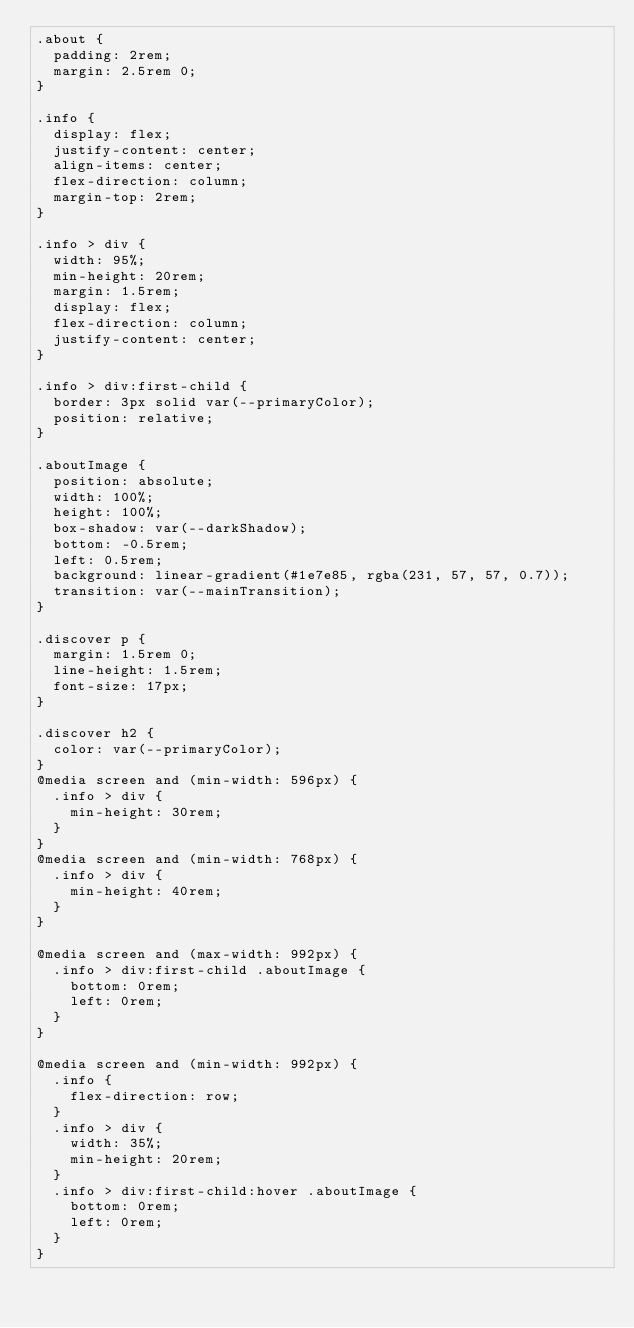<code> <loc_0><loc_0><loc_500><loc_500><_CSS_>.about {
  padding: 2rem;
  margin: 2.5rem 0;
}

.info {
  display: flex;
  justify-content: center;
  align-items: center;
  flex-direction: column;
  margin-top: 2rem;
}

.info > div {
  width: 95%;
  min-height: 20rem;
  margin: 1.5rem;
  display: flex;
  flex-direction: column;
  justify-content: center;
}

.info > div:first-child {
  border: 3px solid var(--primaryColor);
  position: relative;
}

.aboutImage {
  position: absolute;
  width: 100%;
  height: 100%;
  box-shadow: var(--darkShadow);
  bottom: -0.5rem;
  left: 0.5rem;
  background: linear-gradient(#1e7e85, rgba(231, 57, 57, 0.7));
  transition: var(--mainTransition);
}

.discover p {
  margin: 1.5rem 0;
  line-height: 1.5rem;
  font-size: 17px;
}

.discover h2 {
  color: var(--primaryColor);
}
@media screen and (min-width: 596px) {
  .info > div {
    min-height: 30rem;
  }
}
@media screen and (min-width: 768px) {
  .info > div {
    min-height: 40rem;
  }
}

@media screen and (max-width: 992px) {
  .info > div:first-child .aboutImage {
    bottom: 0rem;
    left: 0rem;
  }
}

@media screen and (min-width: 992px) {
  .info {
    flex-direction: row;
  }
  .info > div {
    width: 35%;
    min-height: 20rem;
  }
  .info > div:first-child:hover .aboutImage {
    bottom: 0rem;
    left: 0rem;
  }
}
</code> 